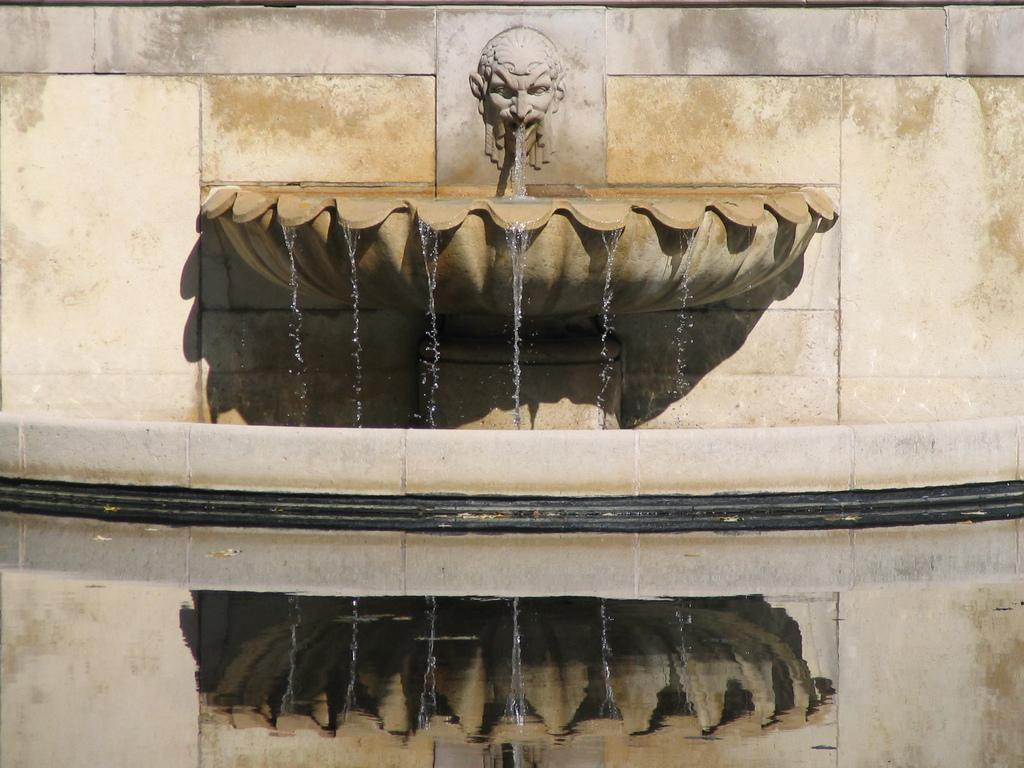Where was the image taken? The image is taken outdoors. What can be seen at the bottom of the image? There is a pond with water at the bottom of the image. What is located in the middle of the image? There is a wall with a carving in the middle of the image, as well as a fountain with water. What type of linen is draped over the fountain in the image? There is no linen present in the image; it features a pond, a wall with a carving, and a fountain with water. 